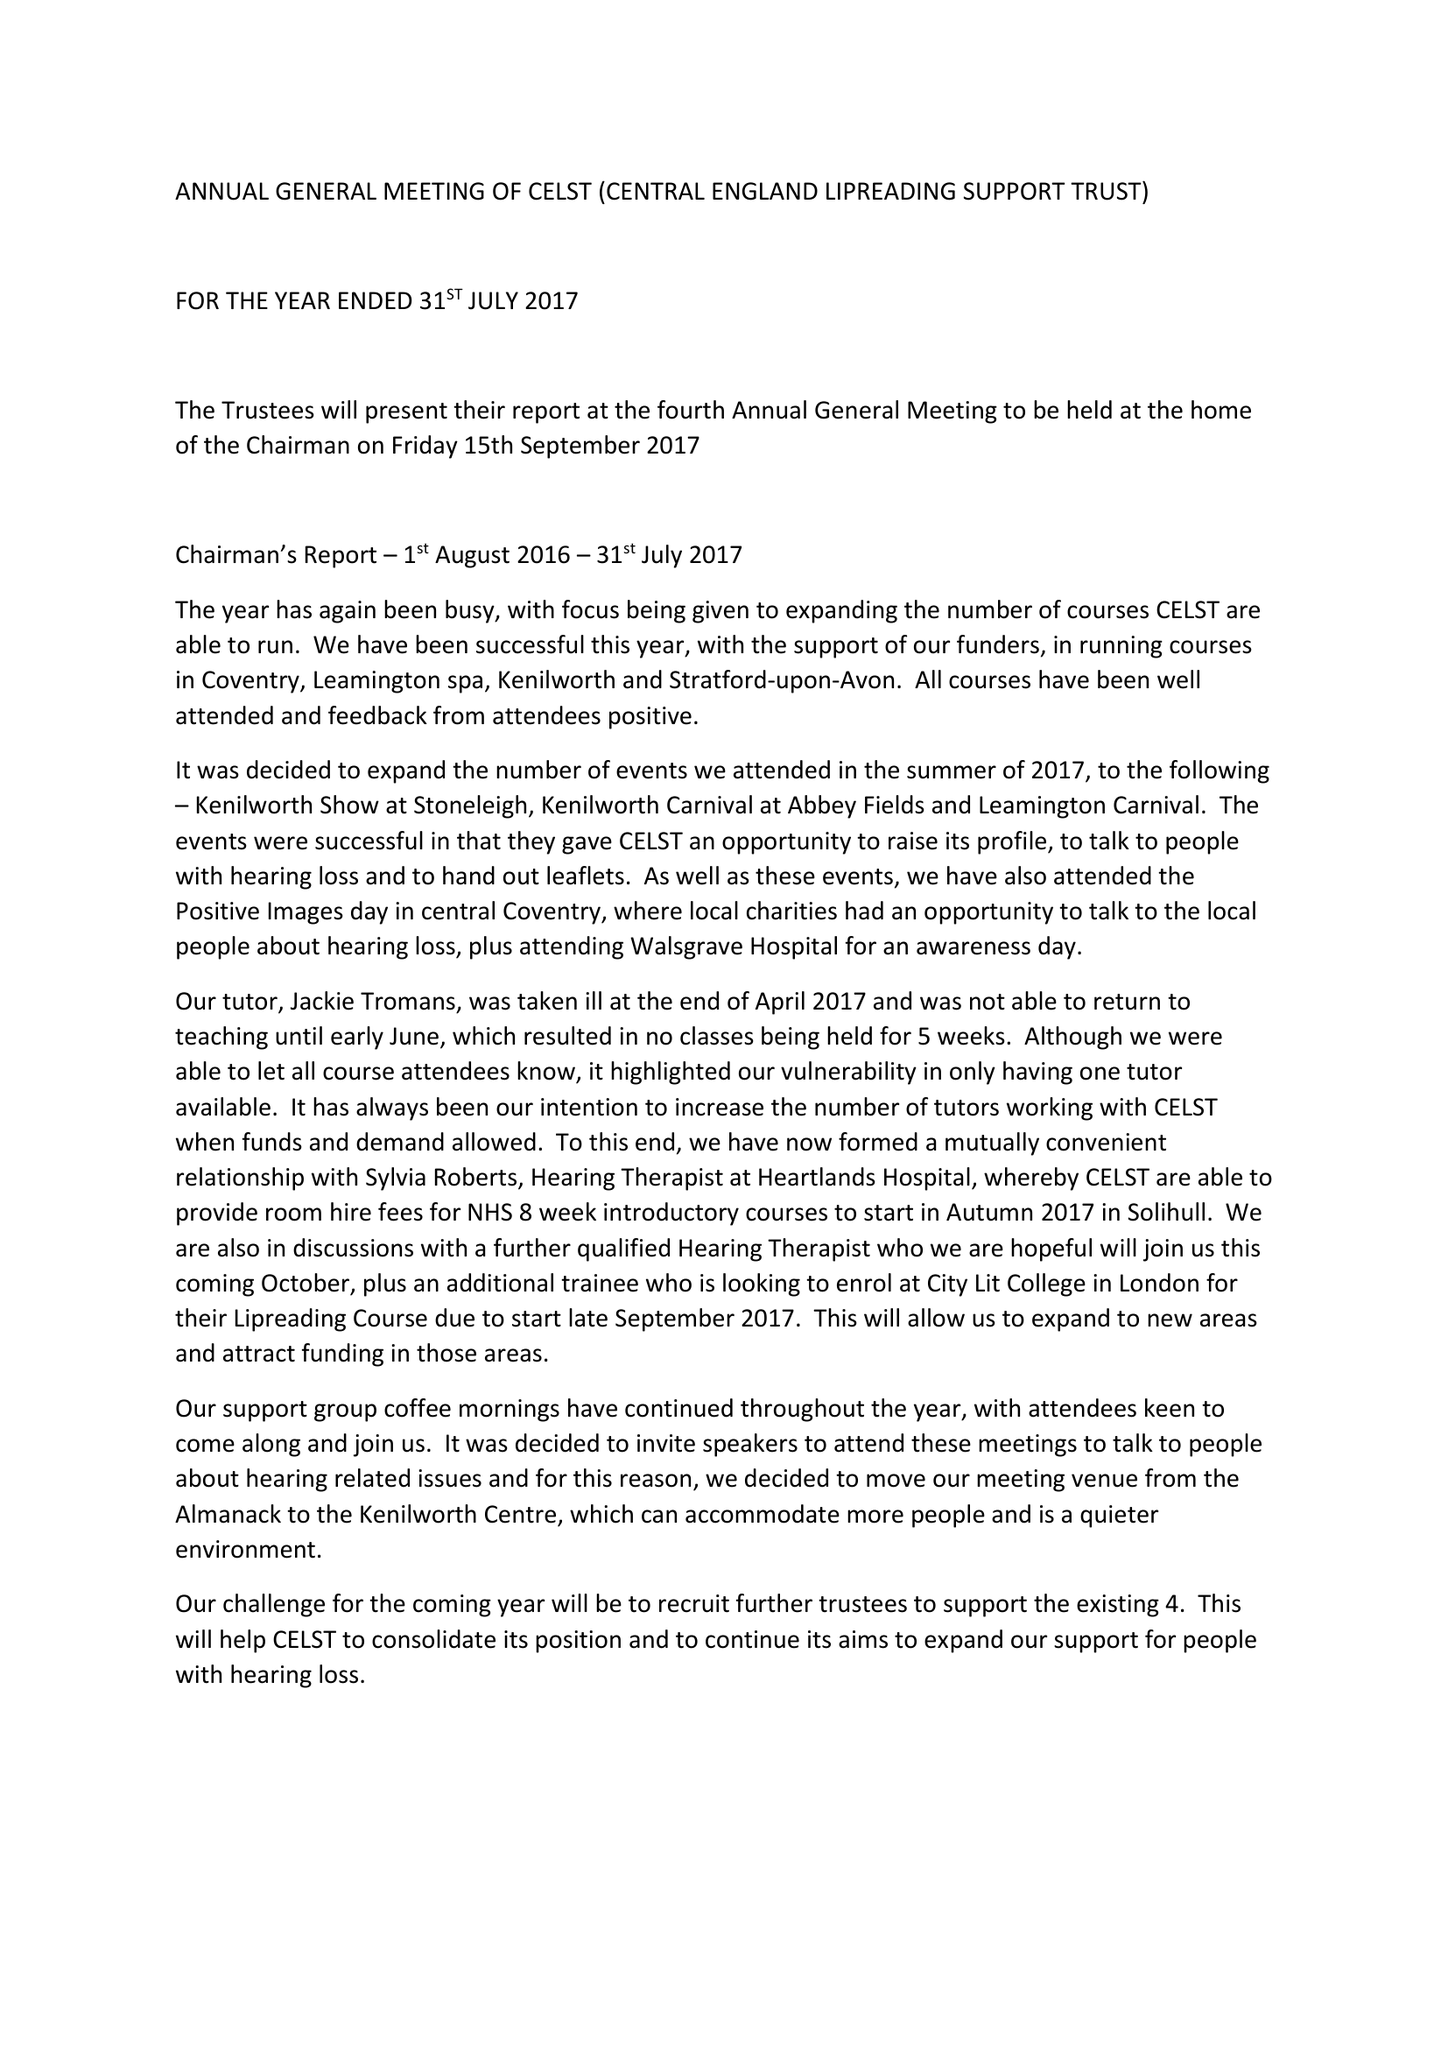What is the value for the charity_number?
Answer the question using a single word or phrase. 1162613 